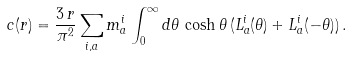<formula> <loc_0><loc_0><loc_500><loc_500>c ( r ) = \frac { 3 \, r } { \pi ^ { 2 } } \sum _ { i , a } m _ { a } ^ { i } \int _ { 0 } ^ { \infty } d \theta \, \cosh \theta \, ( L _ { a } ^ { i } ( \theta ) + L _ { a } ^ { i } ( - \theta ) ) \, .</formula> 